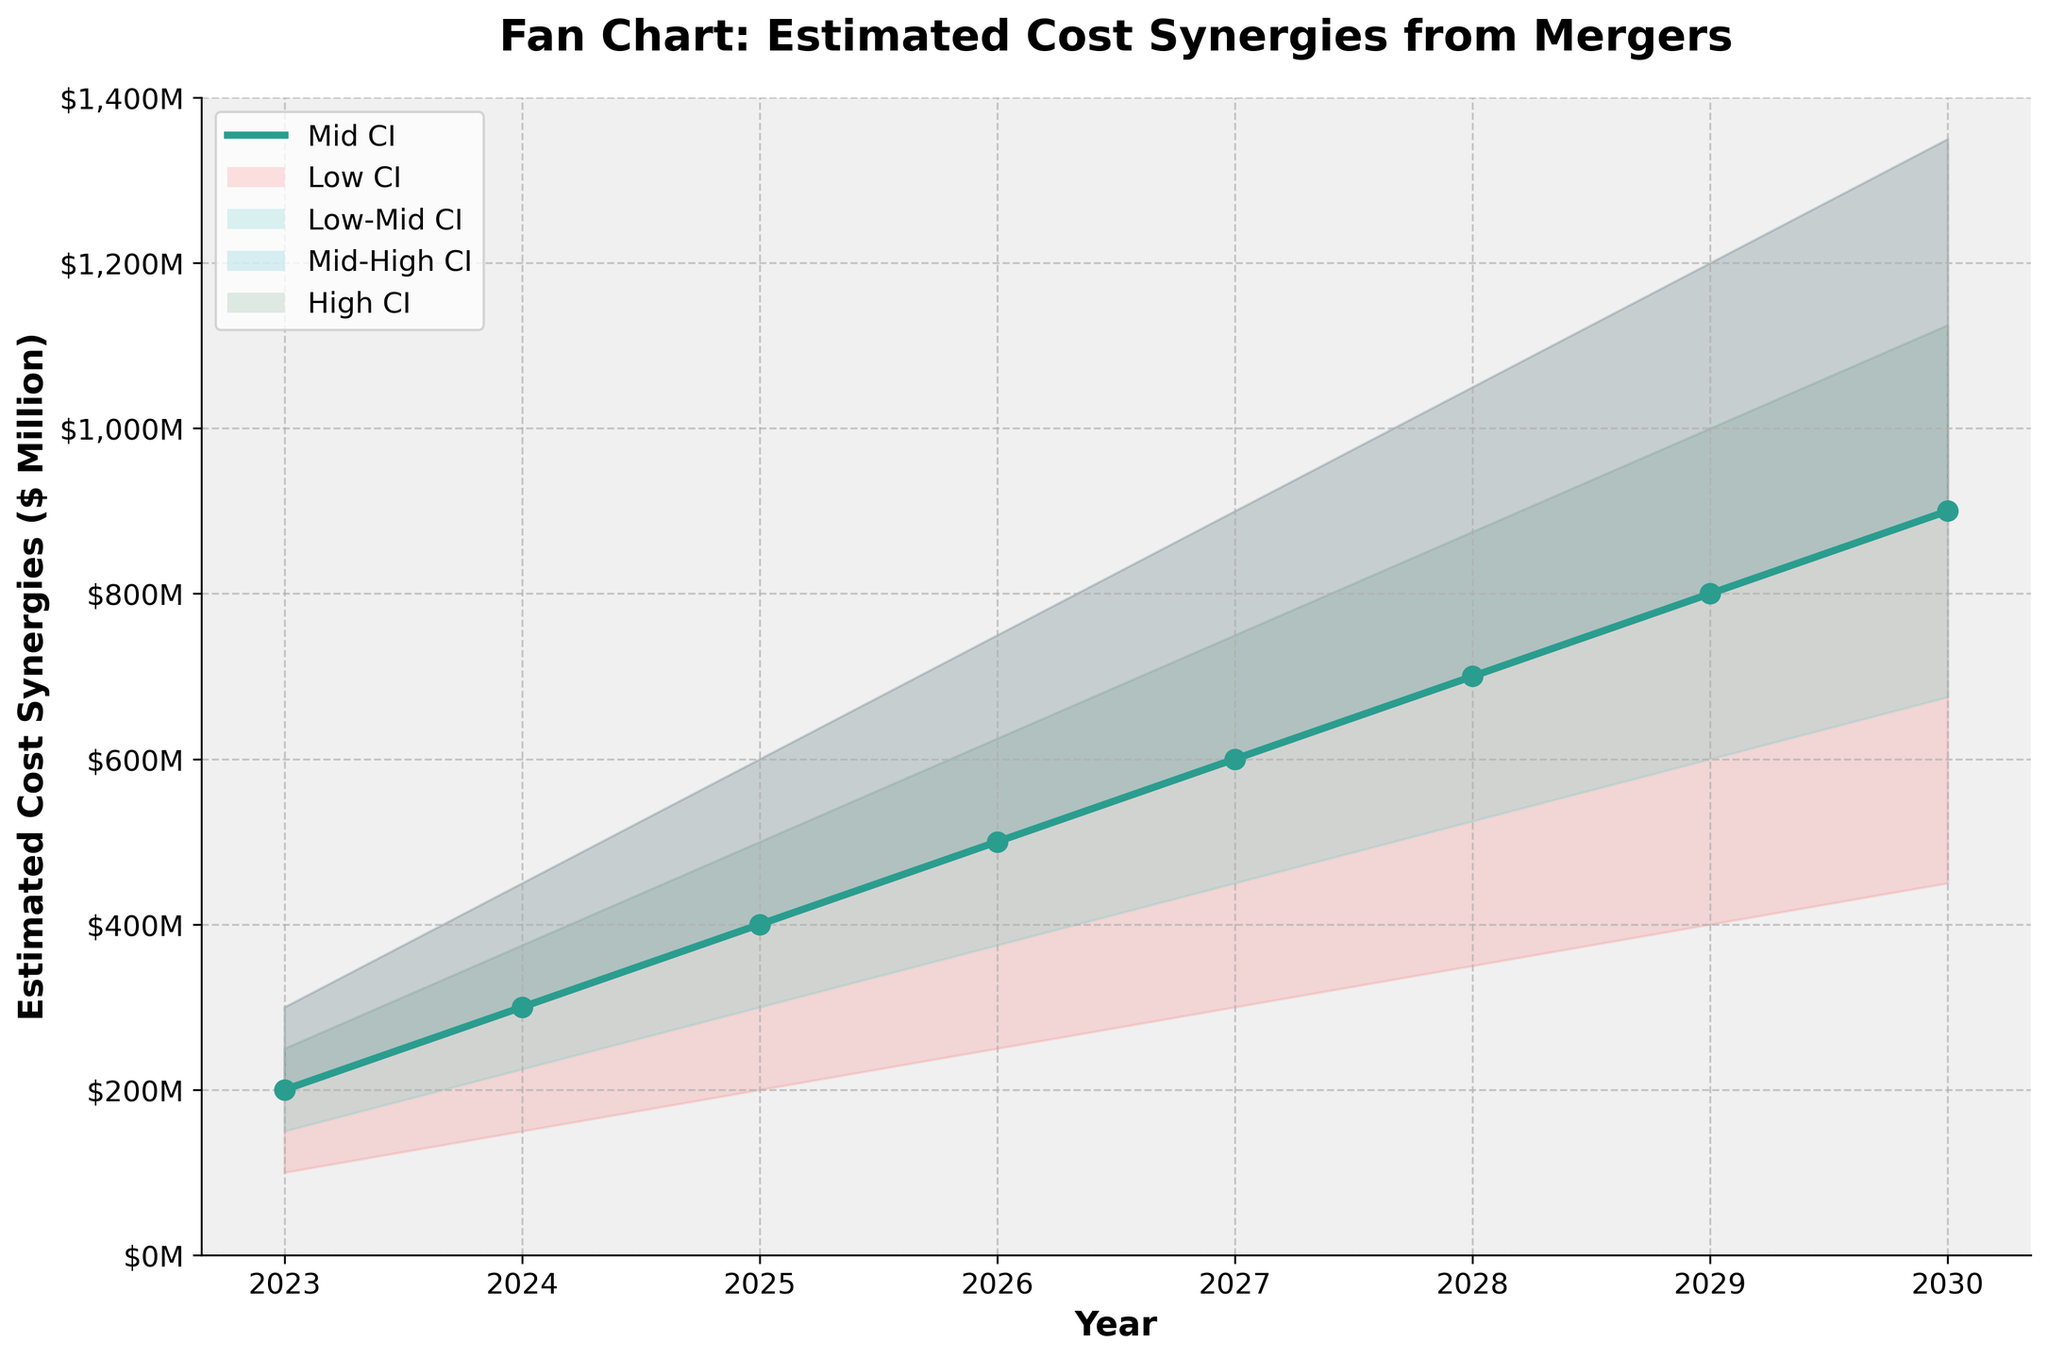Which year has the highest estimated cost synergies in the Mid CI? The Mid CI line is marked by a green line with circle markers. By visually inspecting the plot, the highest point in the Mid CI occurs in 2030 where the value reaches its peak.
Answer: 2030 What is the estimated cost synergy in 2025 for the Low CI? Identify the Low CI section by locating the color representing it (red shaded area). Then, scan across the year 2025 vertically down to the axis marking to find the value. In 2025, the Low CI is 200 million dollars.
Answer: 200 million dollars How much increase in the Mid CI is observed from 2023 to 2024? First, identify the Mid CI values for both years: 200 million dollars in 2023 and 300 million dollars in 2024. The increase is calculated by subtracting the earlier year's value from the later year's value: 300 - 200 = 100 million dollars.
Answer: 100 million dollars Between which years does the estimated cost synergies in the High CI exceed 1000 million dollars? By inspecting the High CI area (dark green shaded section), we find that it exceeds 1000 million dollars starting from 2029 (1000 million) up to 2030 (1350 million dollars).
Answer: 2029 and 2030 What is the average estimated cost synergy in the High CI for the years 2023-2027? To find the average, sum the High CI values for each year from 2023 to 2027 (300, 450, 600, 750, 900): 300 + 450 + 600 + 750 + 900 = 3000 million dollars. Then divide by 5 (number of years): 3000 / 5 = 600 million dollars.
Answer: 600 million dollars Which year shows the smallest spread between the High CI and Low CI? The spread can be calculated by subtracting the Low CI value from the High CI value for each year. The smallest spread is observed by comparing all the values:
- 2023: 300 - 100 = 200 million dollars
- 2024: 450 - 150 = 300 million dollars
- 2025: 600 - 200 = 400 million dollars
- 2026: 750 - 250 = 500 million dollars
- 2027: 900 - 300 = 600 million dollars
- 2028: 1050 - 350 = 700 million dollars
- 2029: 1200 - 400 = 800 million dollars
- 2030: 1350 - 450 = 900 million dollars
The smallest spread is in 2023.
Answer: 2023 How does the trend of the estimated cost synergies in the Mid CI progress over the years? By observing the plot, we can see that the Mid CI follows a consistent upward trend from 200 million dollars in 2023, reaching 900 million dollars in 2030, indicating a steady increase every year.
Answer: Upward trend What is the largest increase in Low-Mid CI values observed between consecutive years? Calculate the differences between the Low-Mid CI values for each consecutive year:
- 2023 to 2024: 225 - 150 = 75 million dollars
- 2024 to 2025: 300 - 225 = 75 million dollars
- 2025 to 2026: 375 - 300 = 75 million dollars
- 2026 to 2027: 450 - 375 = 75 million dollars
- 2027 to 2028: 525 - 450 = 75 million dollars
- 2028 to 2029: 600 - 525 = 75 million dollars
- 2029 to 2030: 675 - 600 = 75 million dollars
All consecutive increases are 75 million dollars.
Answer: 75 million dollars By what percentage do the Mid CI estimated cost synergies increase from 2024 to 2029? Firstly, calculate the difference in the Mid CI values for the two years: 800 - 300 = 500 million dollars. Then, the percentage increase is found by (500/300) * 100 = 166.67%.
Answer: 166.67% 